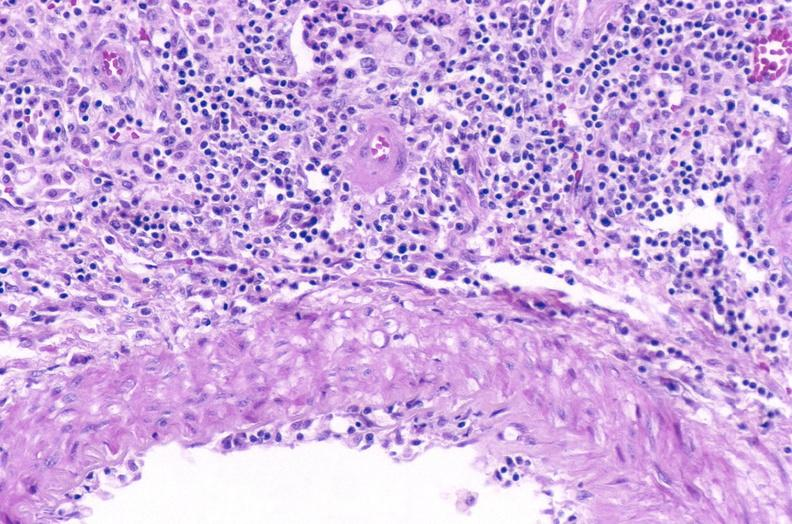what does this image show?
Answer the question using a single word or phrase. Kidney 